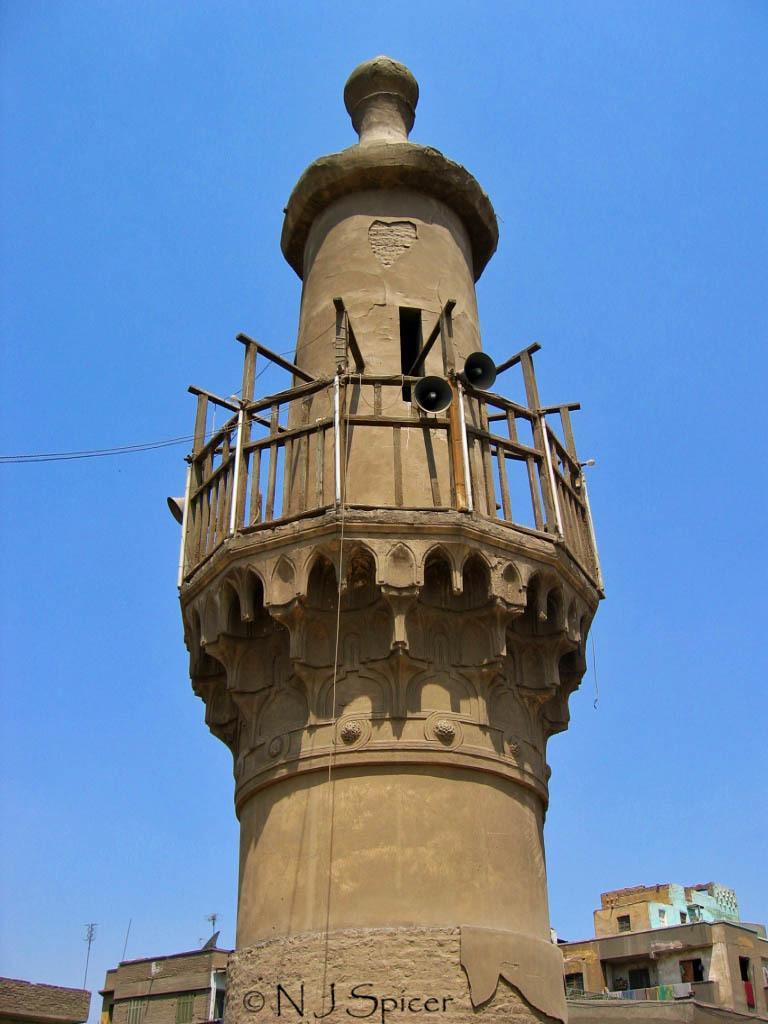Can you describe this image briefly? In this image I can see there is a construction, at the bottom there are houses. In the middle there are speakers to this. At the top it is the sky. 